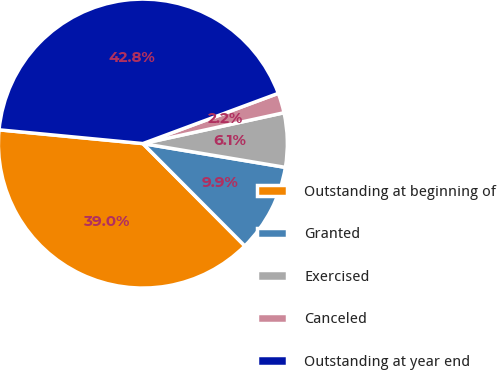Convert chart to OTSL. <chart><loc_0><loc_0><loc_500><loc_500><pie_chart><fcel>Outstanding at beginning of<fcel>Granted<fcel>Exercised<fcel>Canceled<fcel>Outstanding at year end<nl><fcel>38.99%<fcel>9.9%<fcel>6.06%<fcel>2.23%<fcel>42.83%<nl></chart> 